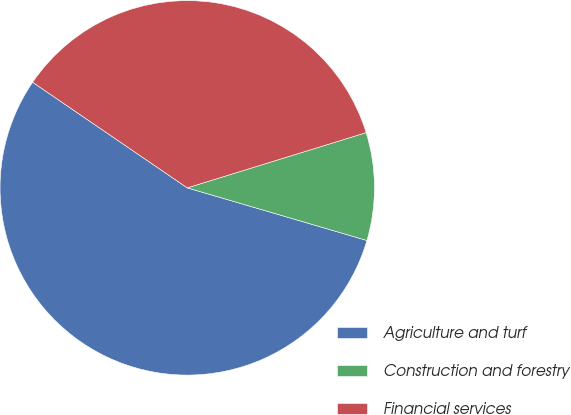<chart> <loc_0><loc_0><loc_500><loc_500><pie_chart><fcel>Agriculture and turf<fcel>Construction and forestry<fcel>Financial services<nl><fcel>55.0%<fcel>9.3%<fcel>35.7%<nl></chart> 